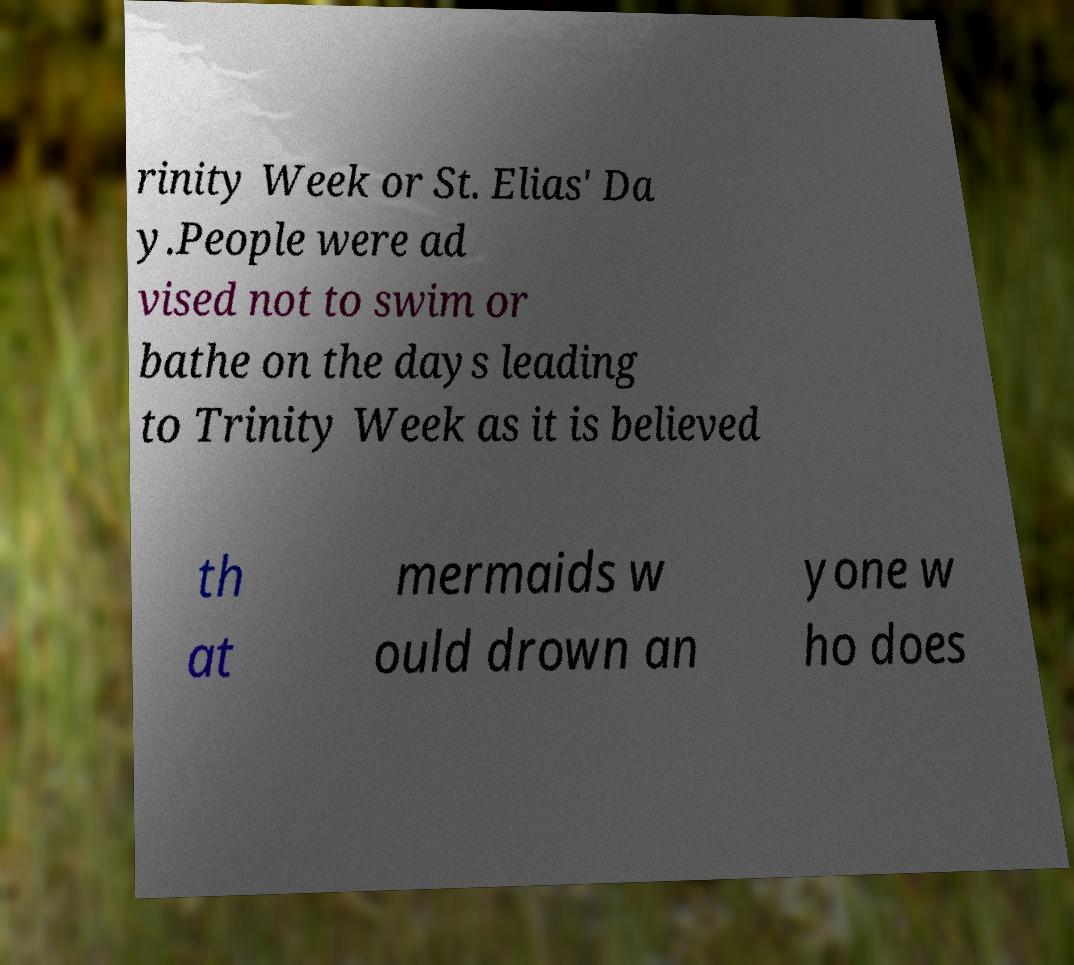Please read and relay the text visible in this image. What does it say? rinity Week or St. Elias' Da y.People were ad vised not to swim or bathe on the days leading to Trinity Week as it is believed th at mermaids w ould drown an yone w ho does 